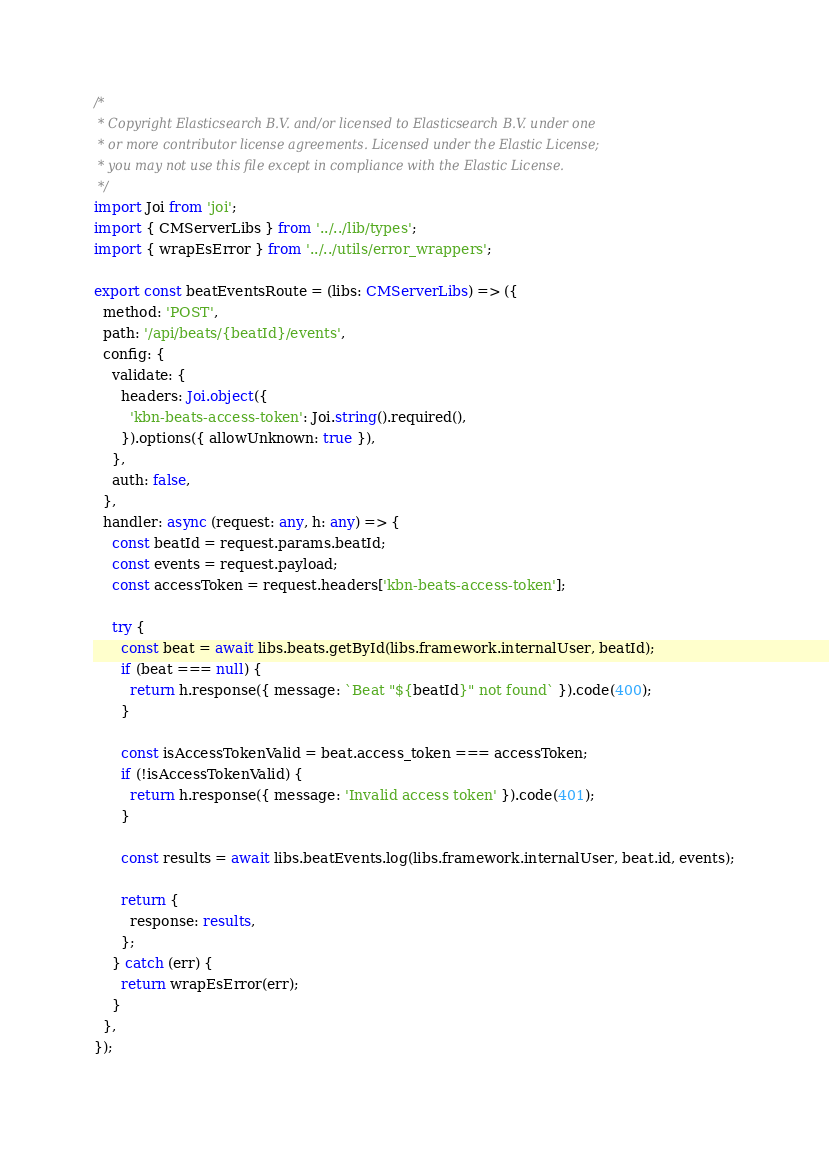<code> <loc_0><loc_0><loc_500><loc_500><_TypeScript_>/*
 * Copyright Elasticsearch B.V. and/or licensed to Elasticsearch B.V. under one
 * or more contributor license agreements. Licensed under the Elastic License;
 * you may not use this file except in compliance with the Elastic License.
 */
import Joi from 'joi';
import { CMServerLibs } from '../../lib/types';
import { wrapEsError } from '../../utils/error_wrappers';

export const beatEventsRoute = (libs: CMServerLibs) => ({
  method: 'POST',
  path: '/api/beats/{beatId}/events',
  config: {
    validate: {
      headers: Joi.object({
        'kbn-beats-access-token': Joi.string().required(),
      }).options({ allowUnknown: true }),
    },
    auth: false,
  },
  handler: async (request: any, h: any) => {
    const beatId = request.params.beatId;
    const events = request.payload;
    const accessToken = request.headers['kbn-beats-access-token'];

    try {
      const beat = await libs.beats.getById(libs.framework.internalUser, beatId);
      if (beat === null) {
        return h.response({ message: `Beat "${beatId}" not found` }).code(400);
      }

      const isAccessTokenValid = beat.access_token === accessToken;
      if (!isAccessTokenValid) {
        return h.response({ message: 'Invalid access token' }).code(401);
      }

      const results = await libs.beatEvents.log(libs.framework.internalUser, beat.id, events);

      return {
        response: results,
      };
    } catch (err) {
      return wrapEsError(err);
    }
  },
});
</code> 